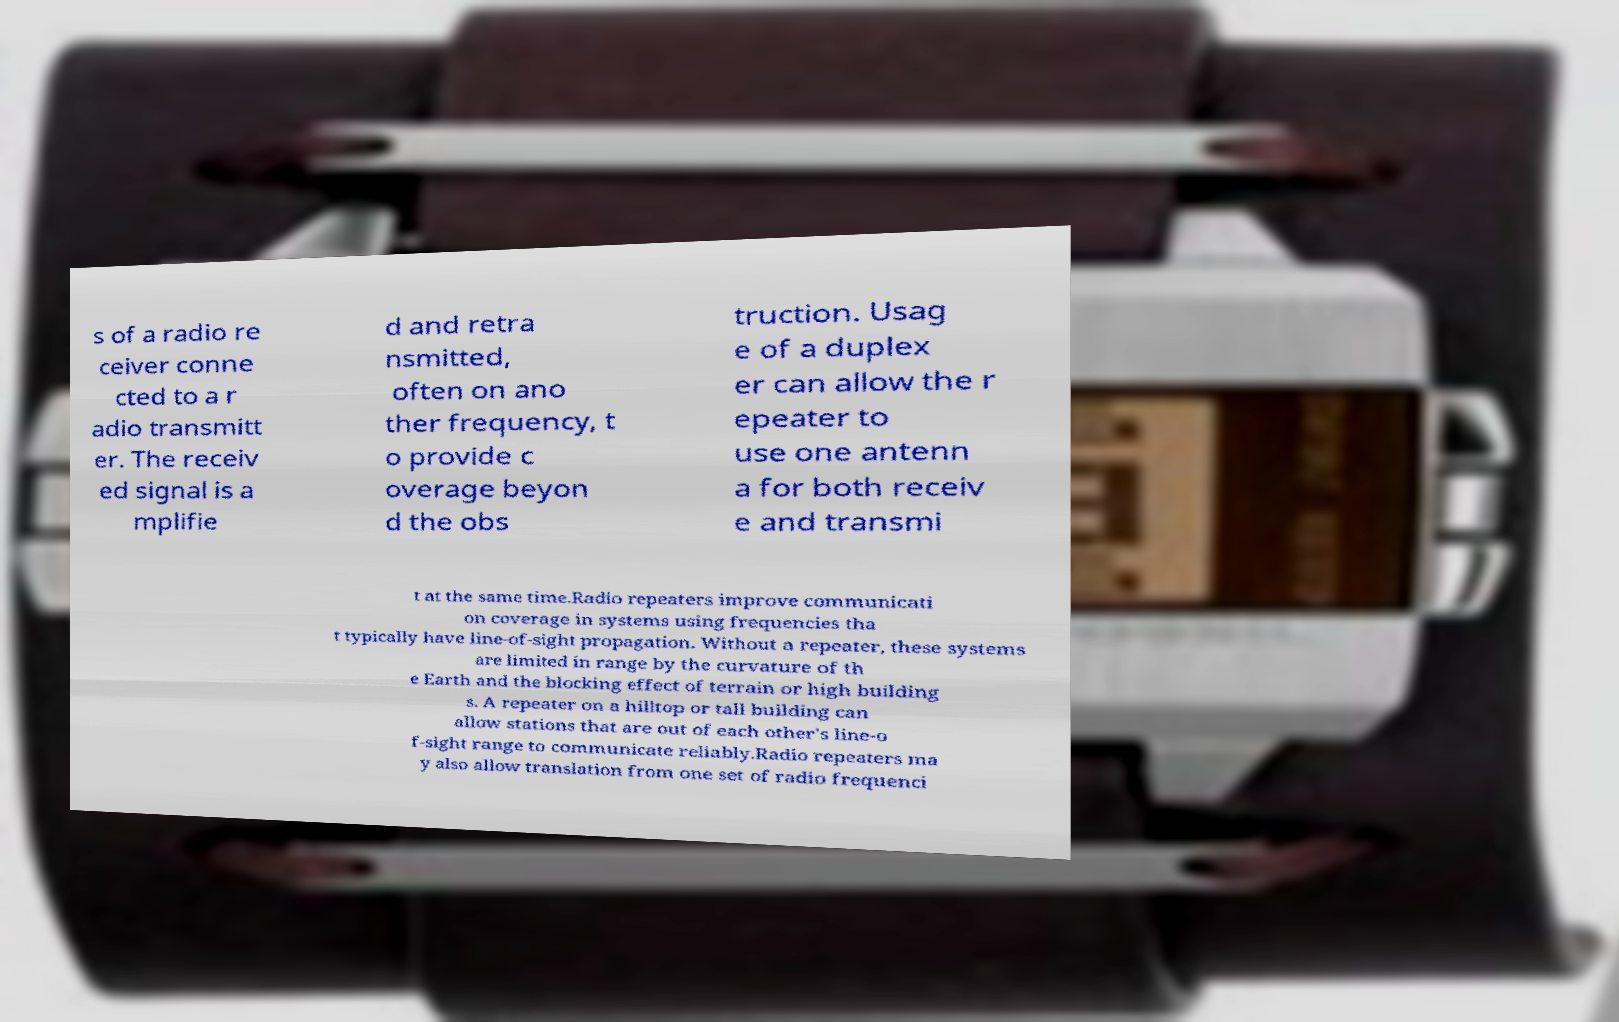Please identify and transcribe the text found in this image. s of a radio re ceiver conne cted to a r adio transmitt er. The receiv ed signal is a mplifie d and retra nsmitted, often on ano ther frequency, t o provide c overage beyon d the obs truction. Usag e of a duplex er can allow the r epeater to use one antenn a for both receiv e and transmi t at the same time.Radio repeaters improve communicati on coverage in systems using frequencies tha t typically have line-of-sight propagation. Without a repeater, these systems are limited in range by the curvature of th e Earth and the blocking effect of terrain or high building s. A repeater on a hilltop or tall building can allow stations that are out of each other's line-o f-sight range to communicate reliably.Radio repeaters ma y also allow translation from one set of radio frequenci 